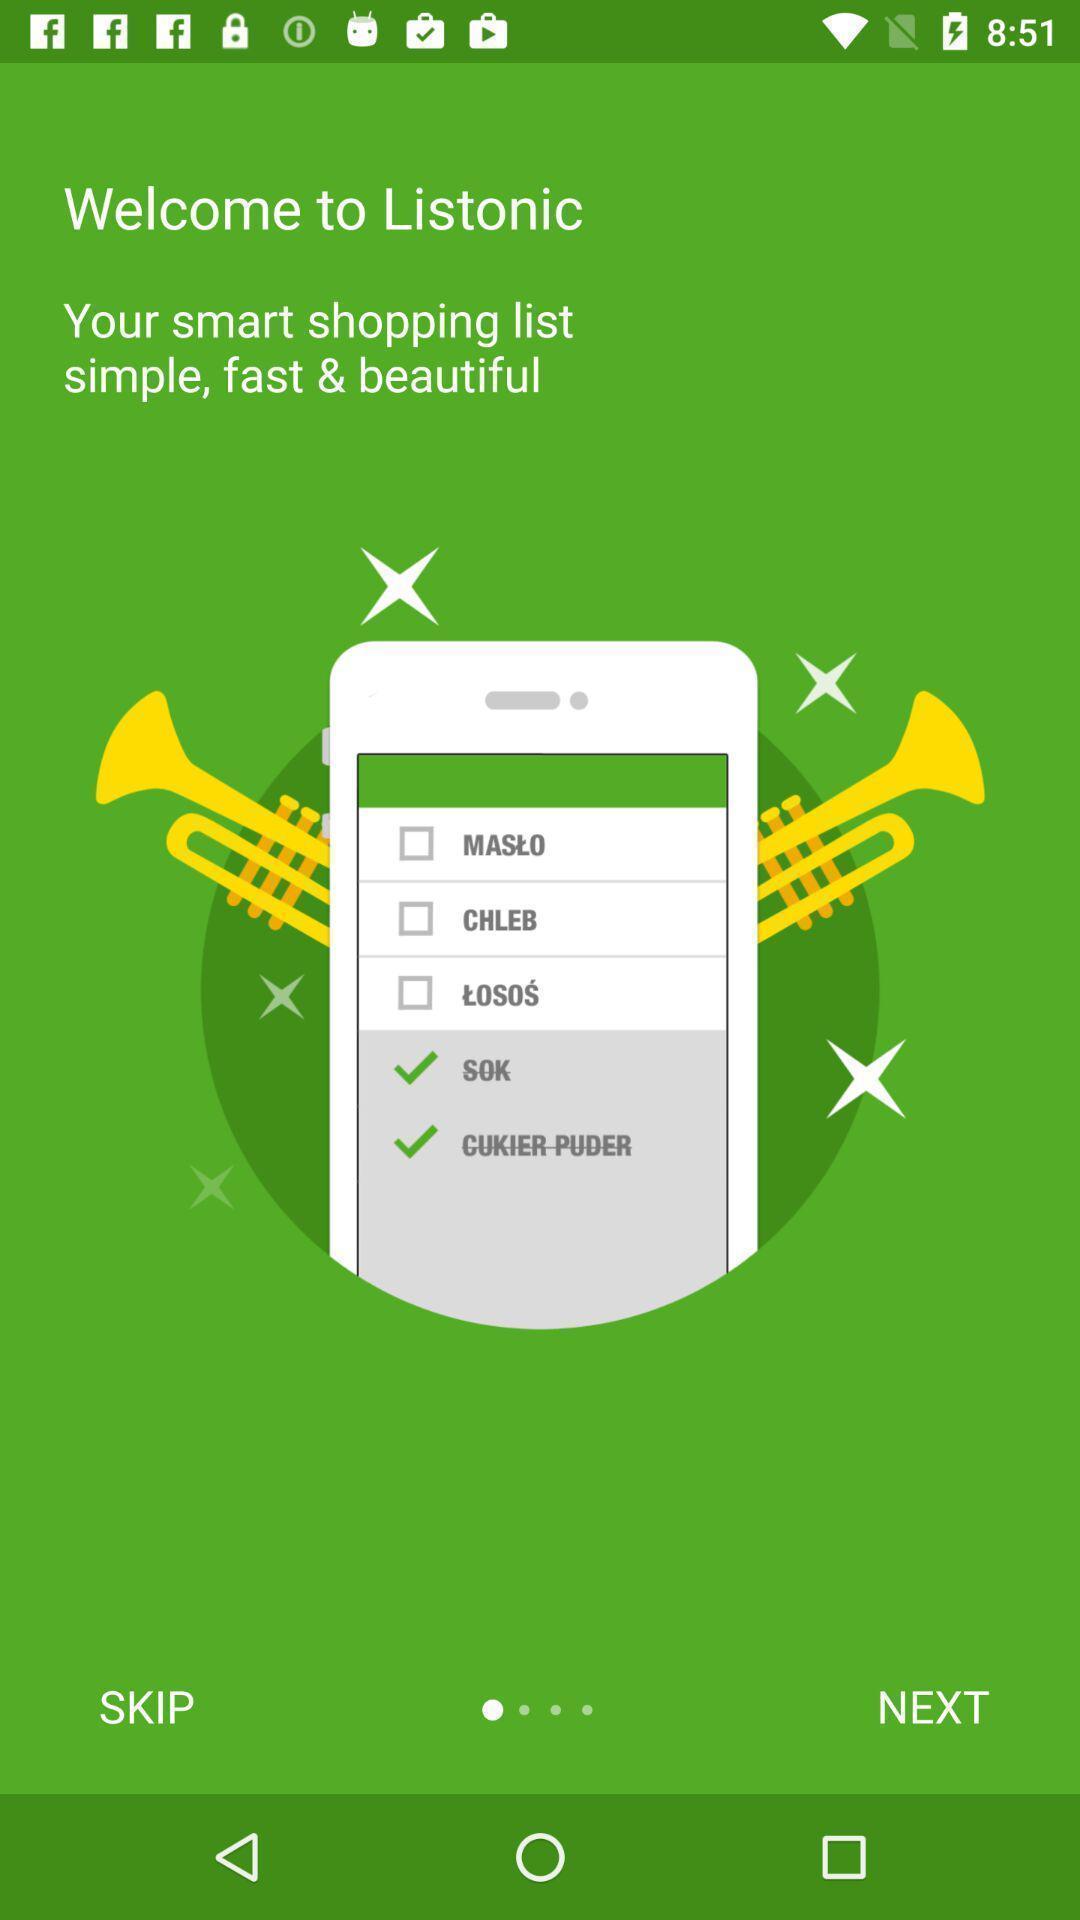Explain the elements present in this screenshot. Welcoming page a shopping app. 